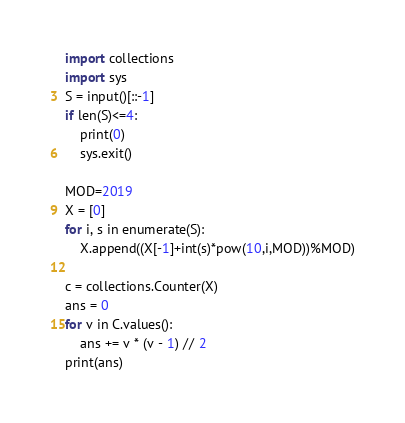Convert code to text. <code><loc_0><loc_0><loc_500><loc_500><_Python_>import collections
import sys
S = input()[::-1]
if len(S)<=4:
    print(0)
    sys.exit()
    
MOD=2019
X = [0]
for i, s in enumerate(S):
    X.append((X[-1]+int(s)*pow(10,i,MOD))%MOD)
    
c = collections.Counter(X)
ans = 0
for v in C.values():
    ans += v * (v - 1) // 2
print(ans)</code> 